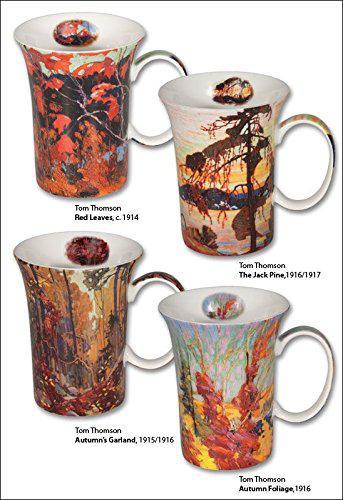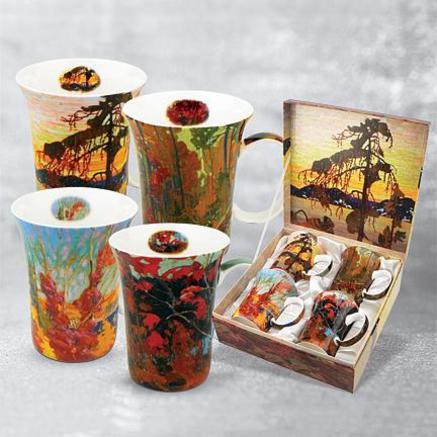The first image is the image on the left, the second image is the image on the right. Examine the images to the left and right. Is the description "Four mugs sit in a case while four sit outside the case in the image on the right." accurate? Answer yes or no. Yes. 